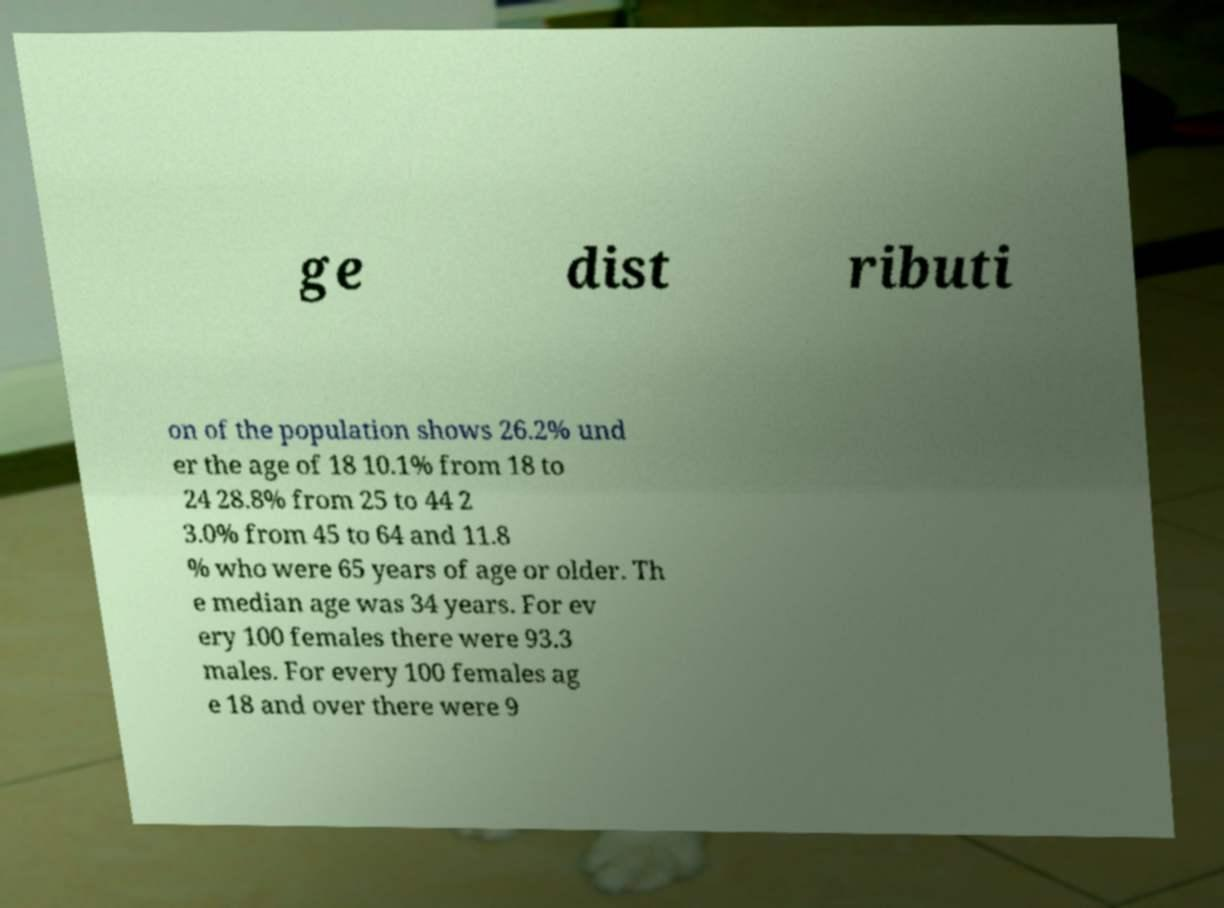For documentation purposes, I need the text within this image transcribed. Could you provide that? ge dist ributi on of the population shows 26.2% und er the age of 18 10.1% from 18 to 24 28.8% from 25 to 44 2 3.0% from 45 to 64 and 11.8 % who were 65 years of age or older. Th e median age was 34 years. For ev ery 100 females there were 93.3 males. For every 100 females ag e 18 and over there were 9 